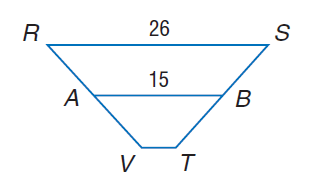Question: For trapezoid R S T V, A and B are midpoints of the legs. Find V T.
Choices:
A. 4
B. 8
C. 26
D. 30
Answer with the letter. Answer: A 